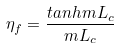Convert formula to latex. <formula><loc_0><loc_0><loc_500><loc_500>\eta _ { f } = \frac { t a n h m L _ { c } } { m L _ { c } }</formula> 